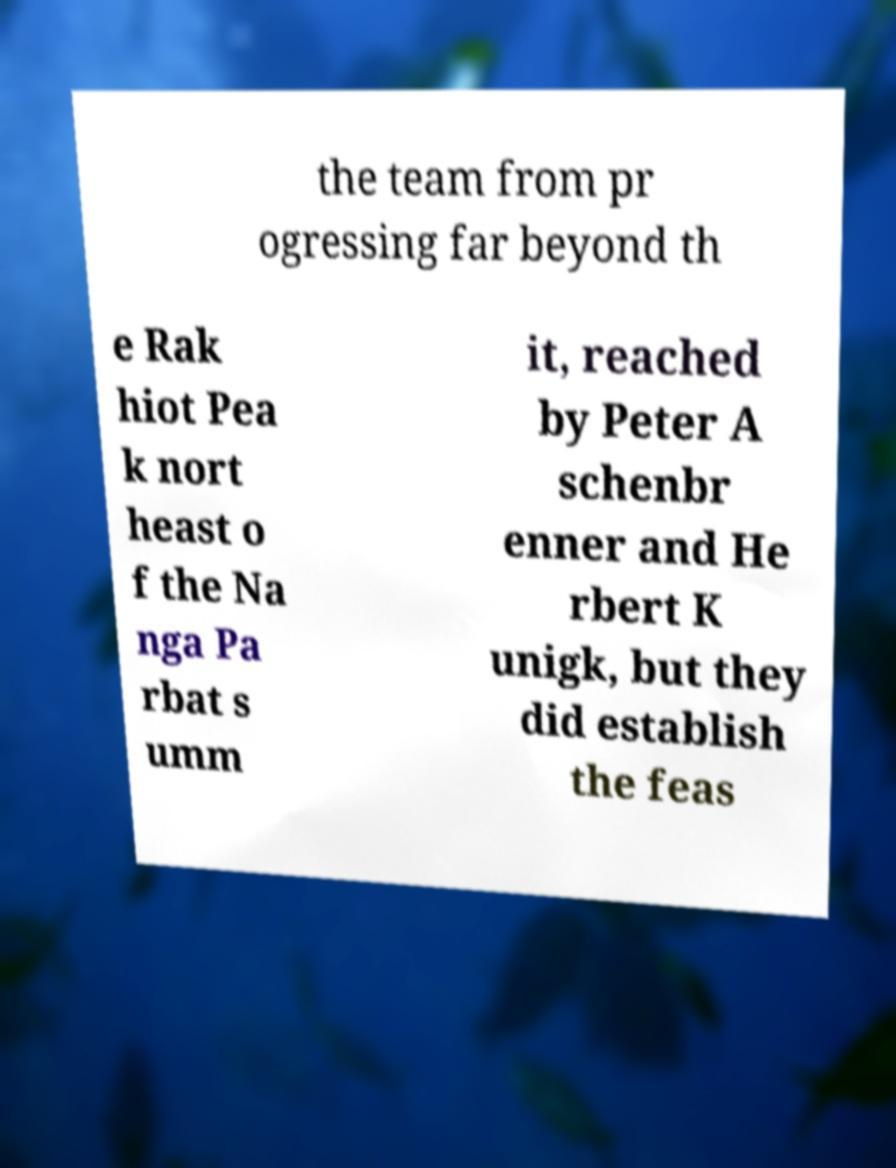Could you assist in decoding the text presented in this image and type it out clearly? the team from pr ogressing far beyond th e Rak hiot Pea k nort heast o f the Na nga Pa rbat s umm it, reached by Peter A schenbr enner and He rbert K unigk, but they did establish the feas 